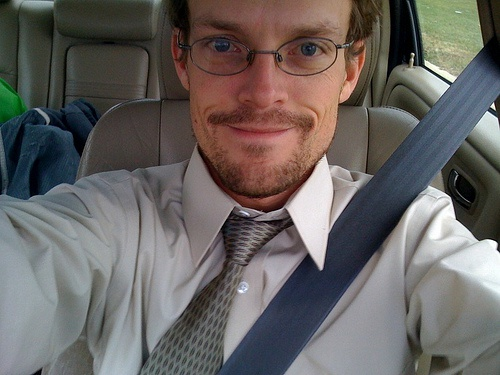Describe the objects in this image and their specific colors. I can see people in black, darkgray, gray, and brown tones and tie in black and gray tones in this image. 